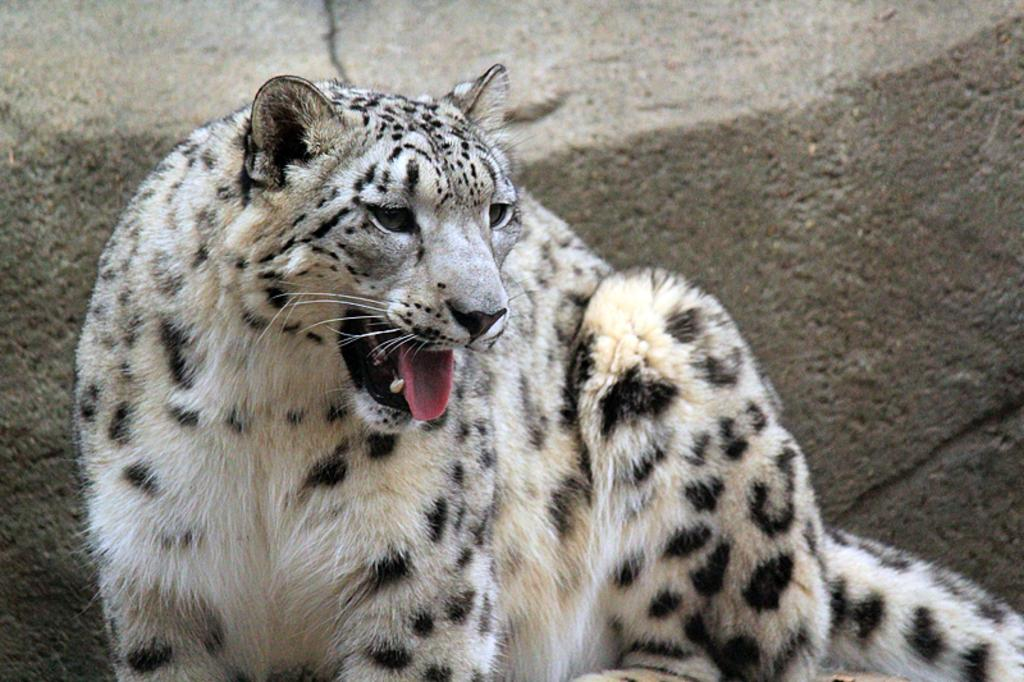What animal is the main subject of the image? There is a tiger in the image. Where is the tiger located in the image? The tiger is in the middle of the image. What color is the tiger in the image? The tiger is white in color. What type of worm can be seen fighting with the tiger in the image? There is no worm present in the image, and the tiger is not engaged in any fight. 